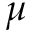Convert formula to latex. <formula><loc_0><loc_0><loc_500><loc_500>\mu</formula> 